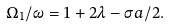<formula> <loc_0><loc_0><loc_500><loc_500>\Omega _ { 1 } / \omega = 1 + 2 \lambda - \sigma a / 2 .</formula> 